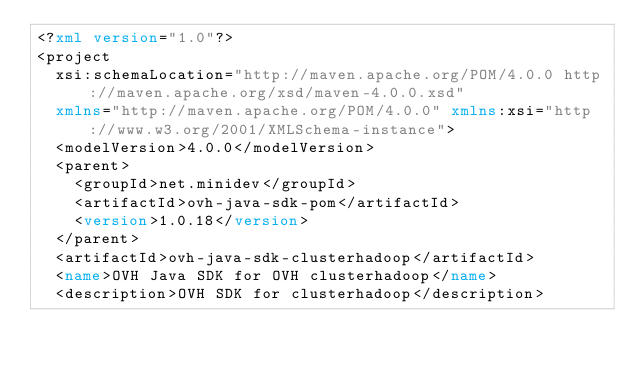<code> <loc_0><loc_0><loc_500><loc_500><_XML_><?xml version="1.0"?>
<project
	xsi:schemaLocation="http://maven.apache.org/POM/4.0.0 http://maven.apache.org/xsd/maven-4.0.0.xsd"
	xmlns="http://maven.apache.org/POM/4.0.0" xmlns:xsi="http://www.w3.org/2001/XMLSchema-instance">
	<modelVersion>4.0.0</modelVersion>
	<parent>
		<groupId>net.minidev</groupId>
		<artifactId>ovh-java-sdk-pom</artifactId>
		<version>1.0.18</version>
	</parent>
	<artifactId>ovh-java-sdk-clusterhadoop</artifactId>
	<name>OVH Java SDK for OVH clusterhadoop</name>
	<description>OVH SDK for clusterhadoop</description></code> 